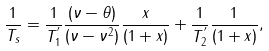<formula> <loc_0><loc_0><loc_500><loc_500>\frac { 1 } { T _ { s } } = \frac { 1 } { { T } _ { 1 } ^ { ^ { \prime } } } \frac { ( \nu - \theta ) } { ( \nu - \nu ^ { 2 } ) } \frac { x } { ( 1 + x ) } + \frac { 1 } { { T } _ { 2 } ^ { ^ { \prime } } } \frac { 1 } { ( 1 + x ) } ,</formula> 